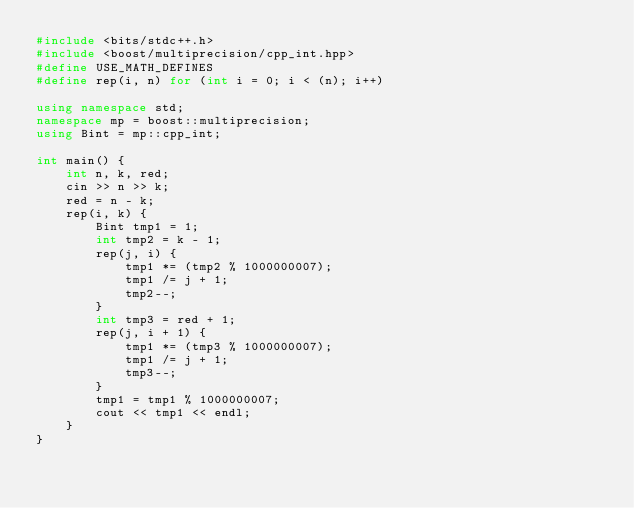Convert code to text. <code><loc_0><loc_0><loc_500><loc_500><_C++_>#include <bits/stdc++.h>
#include <boost/multiprecision/cpp_int.hpp>
#define USE_MATH_DEFINES
#define rep(i, n) for (int i = 0; i < (n); i++)

using namespace std;
namespace mp = boost::multiprecision;
using Bint = mp::cpp_int;

int main() {
    int n, k, red;
    cin >> n >> k;
    red = n - k;
    rep(i, k) {
        Bint tmp1 = 1;
        int tmp2 = k - 1;
        rep(j, i) {
            tmp1 *= (tmp2 % 1000000007);
            tmp1 /= j + 1;
            tmp2--;
        }
        int tmp3 = red + 1;
        rep(j, i + 1) {
            tmp1 *= (tmp3 % 1000000007);
            tmp1 /= j + 1;
            tmp3--;
        }
        tmp1 = tmp1 % 1000000007;
        cout << tmp1 << endl;
    }
}</code> 